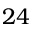<formula> <loc_0><loc_0><loc_500><loc_500>2 4</formula> 